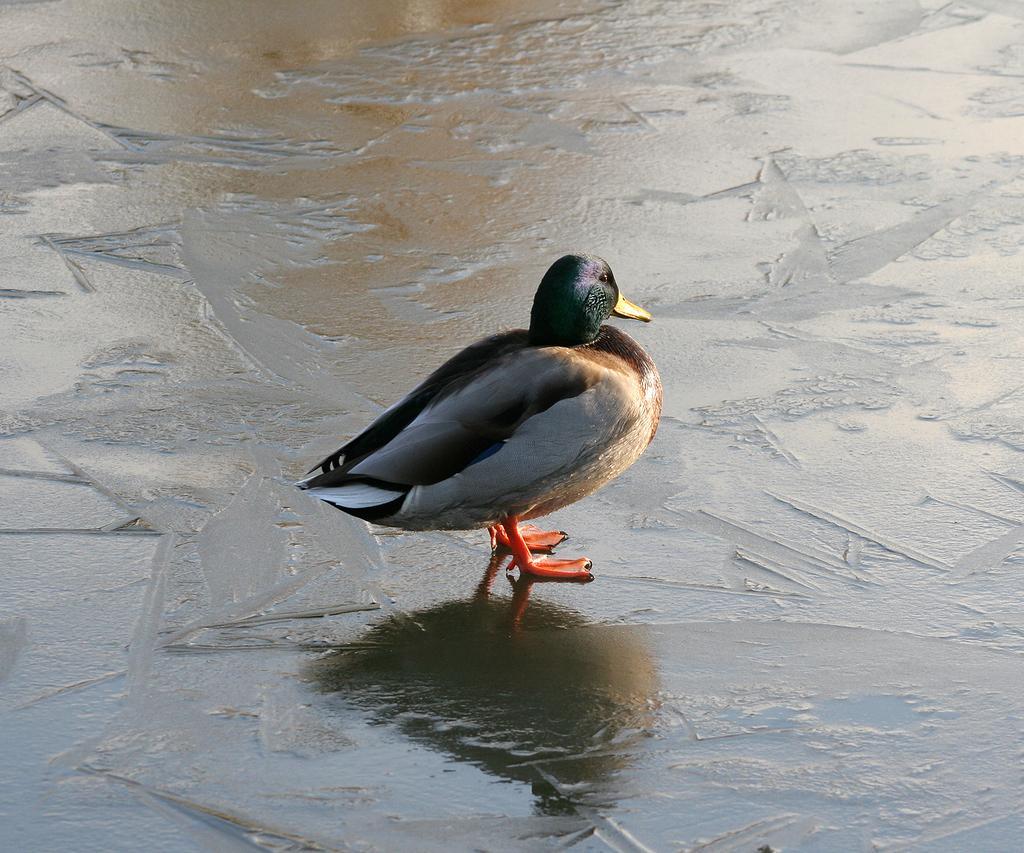Please provide a concise description of this image. In this picture, we can see a bird on the wet ground. 